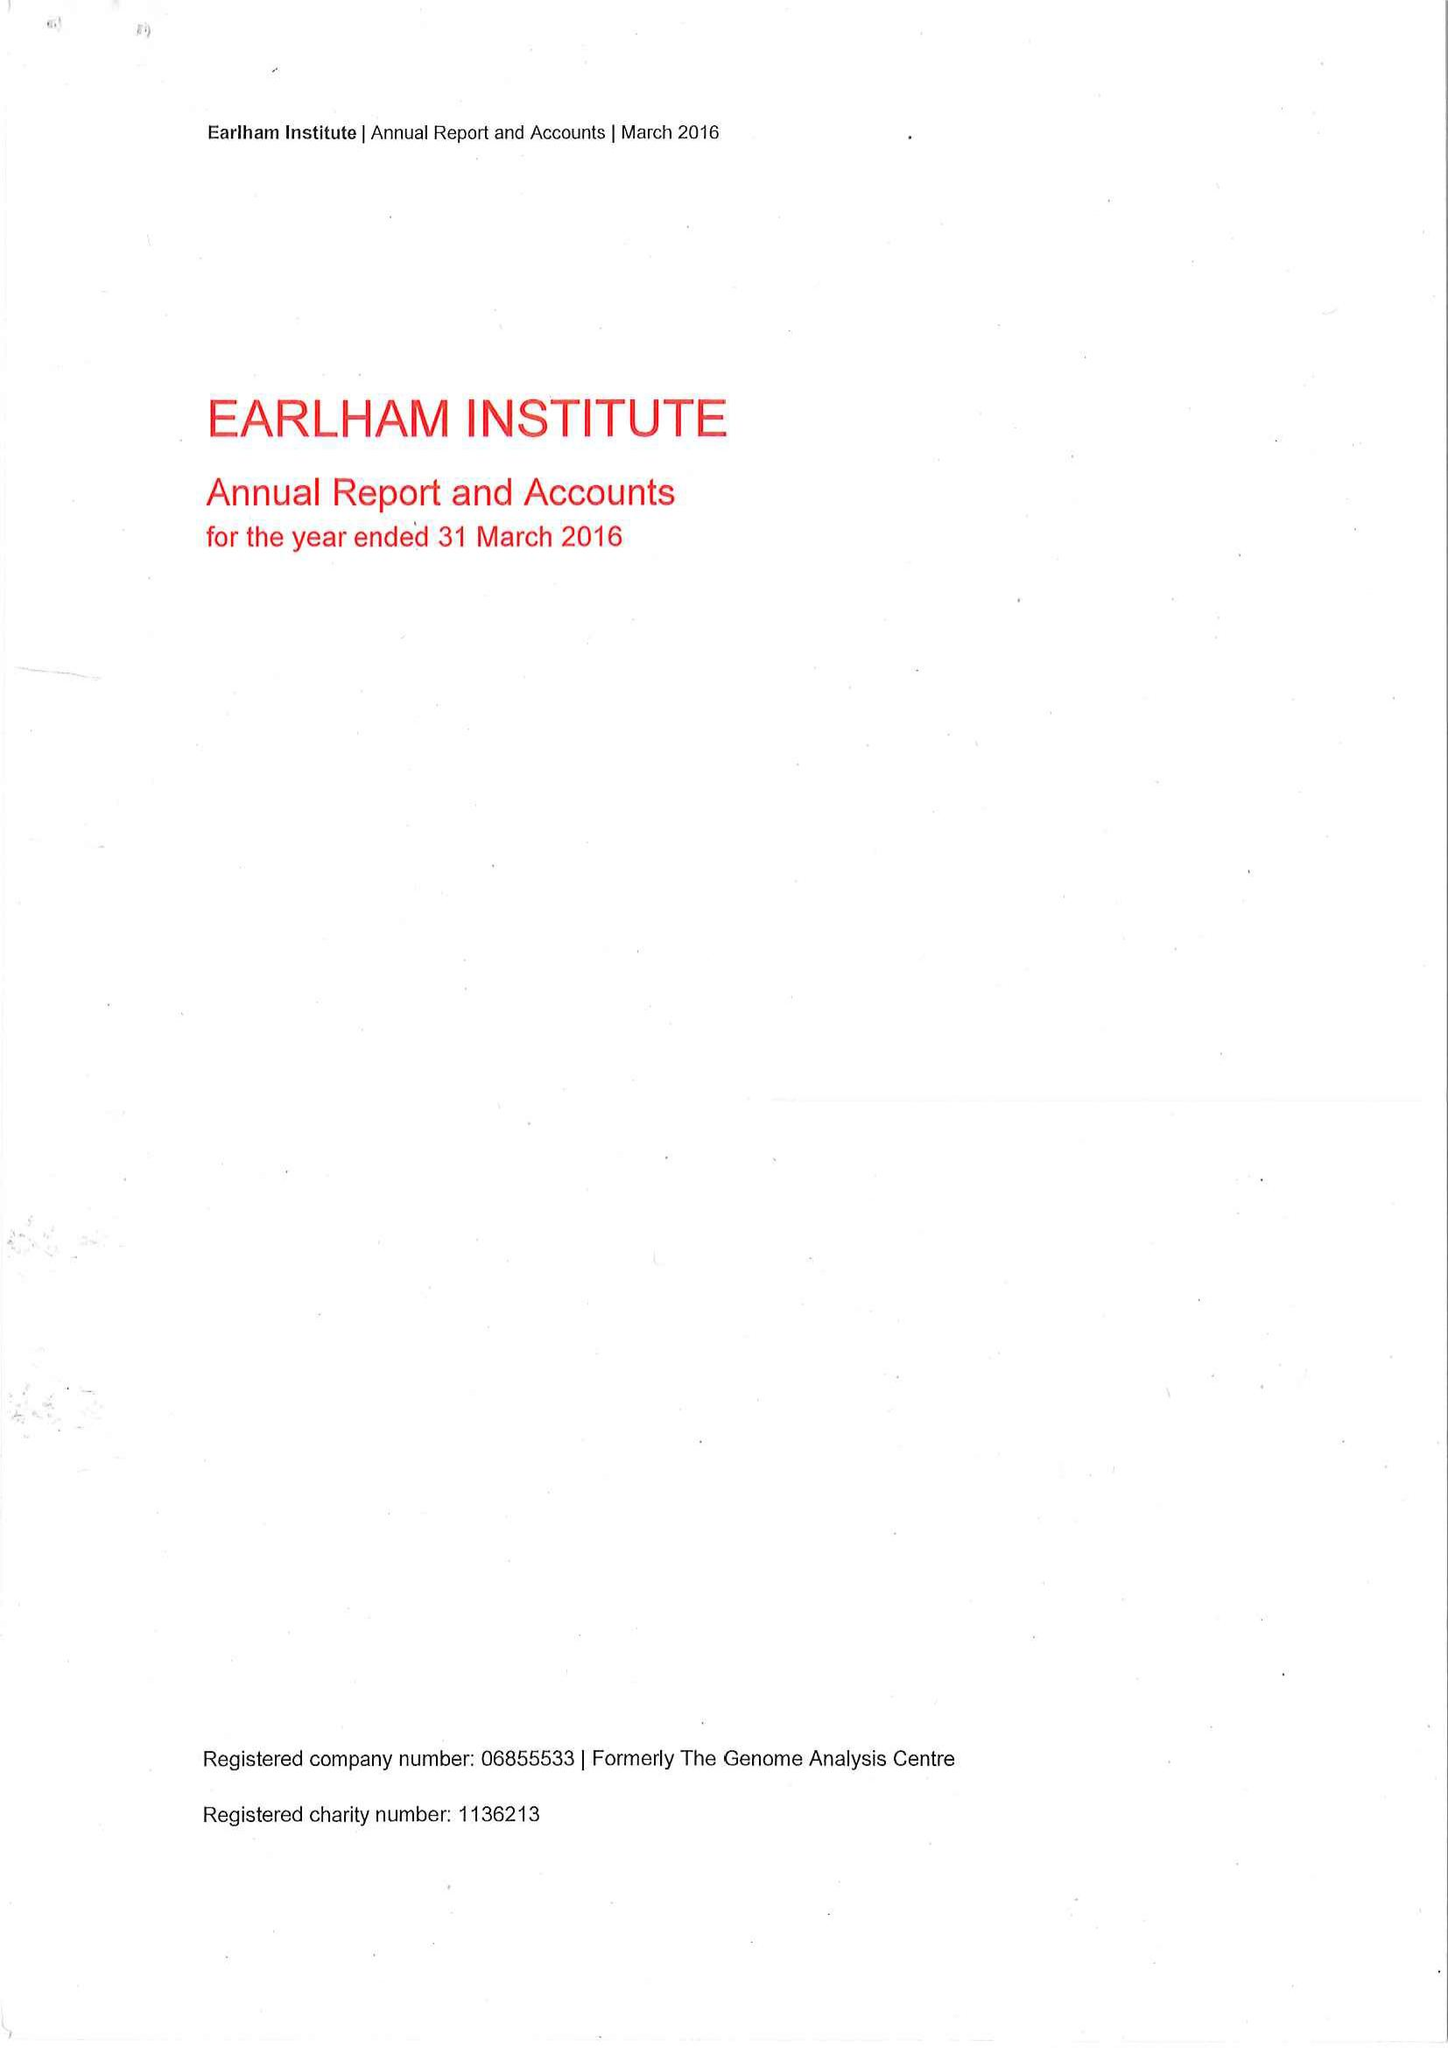What is the value for the income_annually_in_british_pounds?
Answer the question using a single word or phrase. 14921000.00 